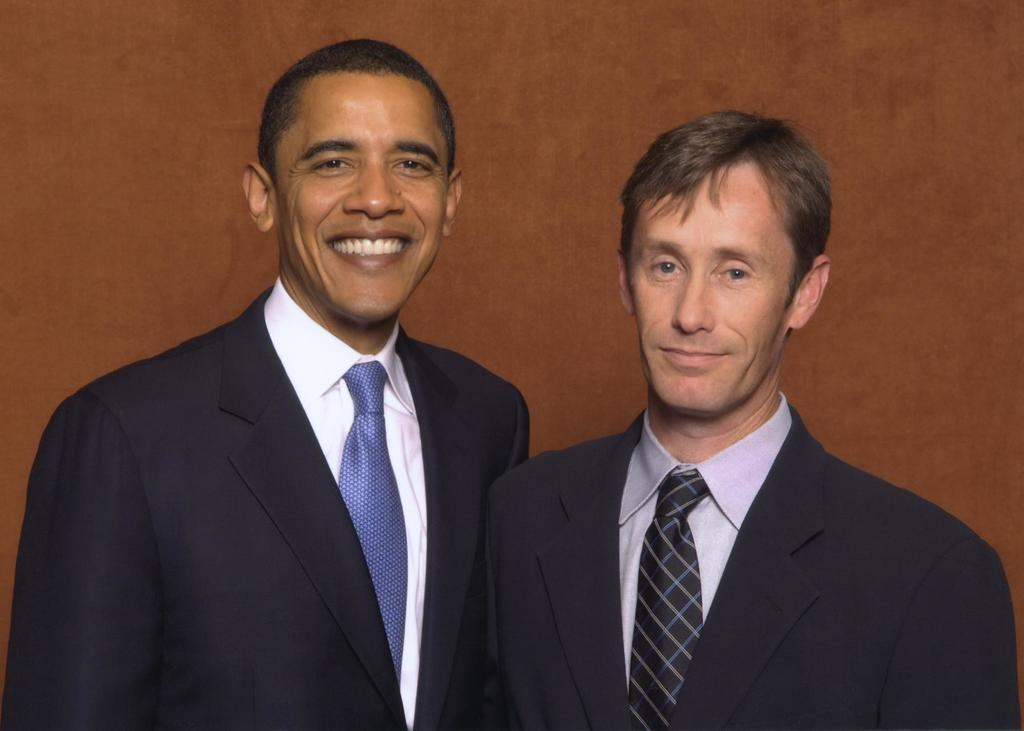How many people are in the image? There are two men in the image. What are the men doing in the image? The men are standing in the image. What type of clothing are the men wearing on their upper bodies? The men are wearing blazers, shirts, and ties in the image. What can be seen in the background of the image? There is a brown wall in the background of the image. Are there any cherries hanging from the brown wall in the image? There are no cherries visible in the image, and they are not mentioned in the provided facts. Is there an actor in the image? The provided facts do not mention any actors, so we cannot determine if there is an actor in the image. 